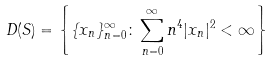Convert formula to latex. <formula><loc_0><loc_0><loc_500><loc_500>D ( S ) = \left \{ \{ x _ { n } \} _ { n = 0 } ^ { \infty } \colon \sum _ { n = 0 } ^ { \infty } n ^ { 4 } | x _ { n } | ^ { 2 } < \infty \right \}</formula> 